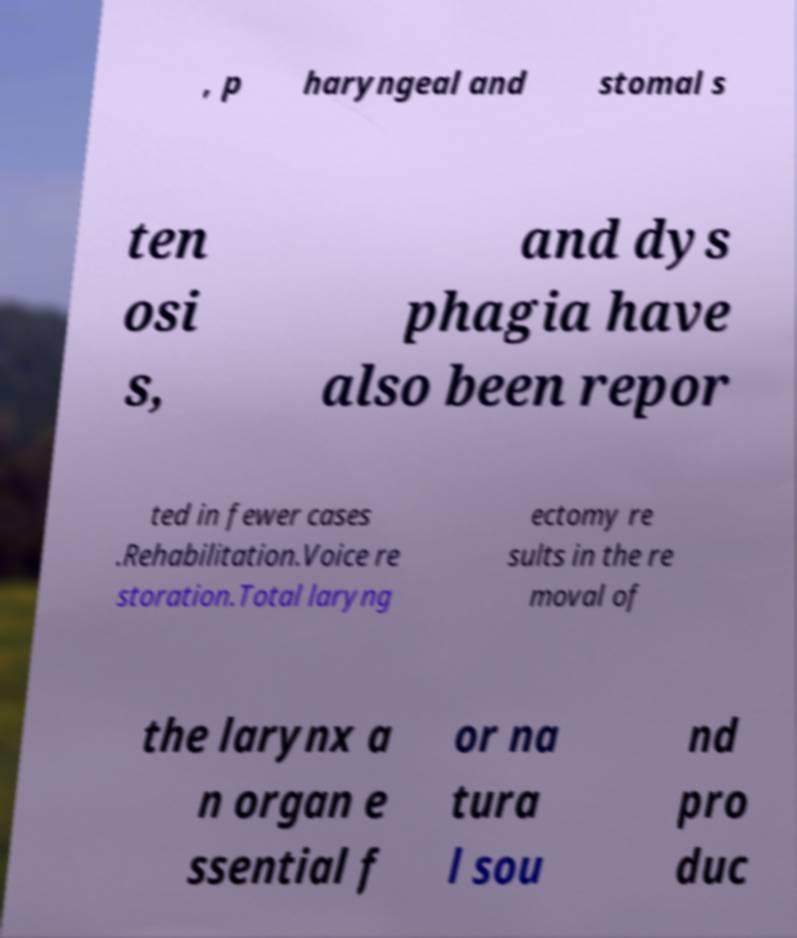I need the written content from this picture converted into text. Can you do that? , p haryngeal and stomal s ten osi s, and dys phagia have also been repor ted in fewer cases .Rehabilitation.Voice re storation.Total laryng ectomy re sults in the re moval of the larynx a n organ e ssential f or na tura l sou nd pro duc 